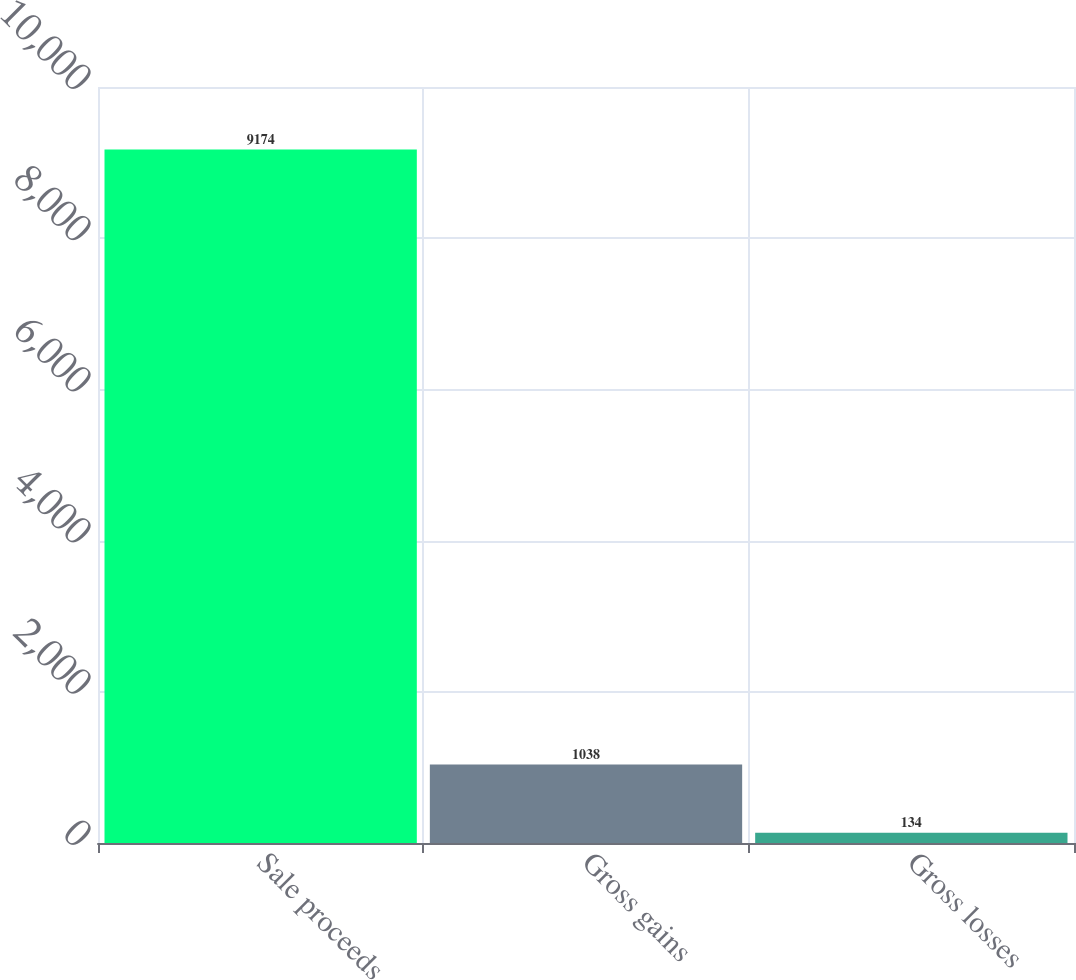Convert chart to OTSL. <chart><loc_0><loc_0><loc_500><loc_500><bar_chart><fcel>Sale proceeds<fcel>Gross gains<fcel>Gross losses<nl><fcel>9174<fcel>1038<fcel>134<nl></chart> 